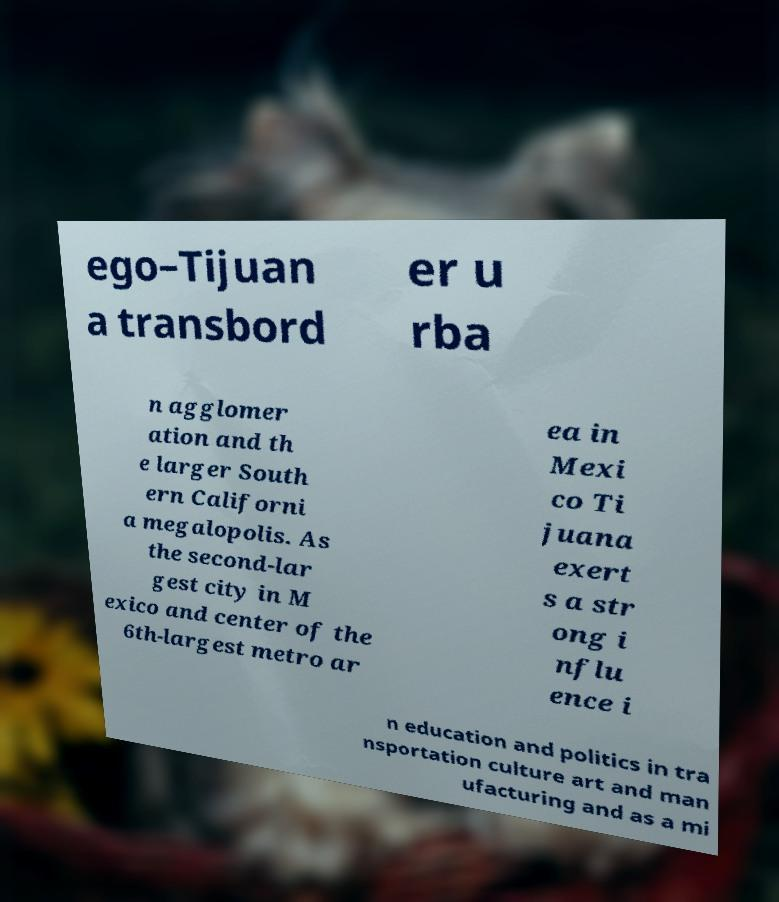Can you read and provide the text displayed in the image?This photo seems to have some interesting text. Can you extract and type it out for me? ego–Tijuan a transbord er u rba n agglomer ation and th e larger South ern Californi a megalopolis. As the second-lar gest city in M exico and center of the 6th-largest metro ar ea in Mexi co Ti juana exert s a str ong i nflu ence i n education and politics in tra nsportation culture art and man ufacturing and as a mi 